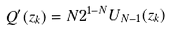Convert formula to latex. <formula><loc_0><loc_0><loc_500><loc_500>Q ^ { \prime } ( z _ { k } ) = N 2 ^ { 1 - N } U _ { N - 1 } ( z _ { k } )</formula> 